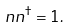<formula> <loc_0><loc_0><loc_500><loc_500>n n ^ { \dagger } = 1 .</formula> 